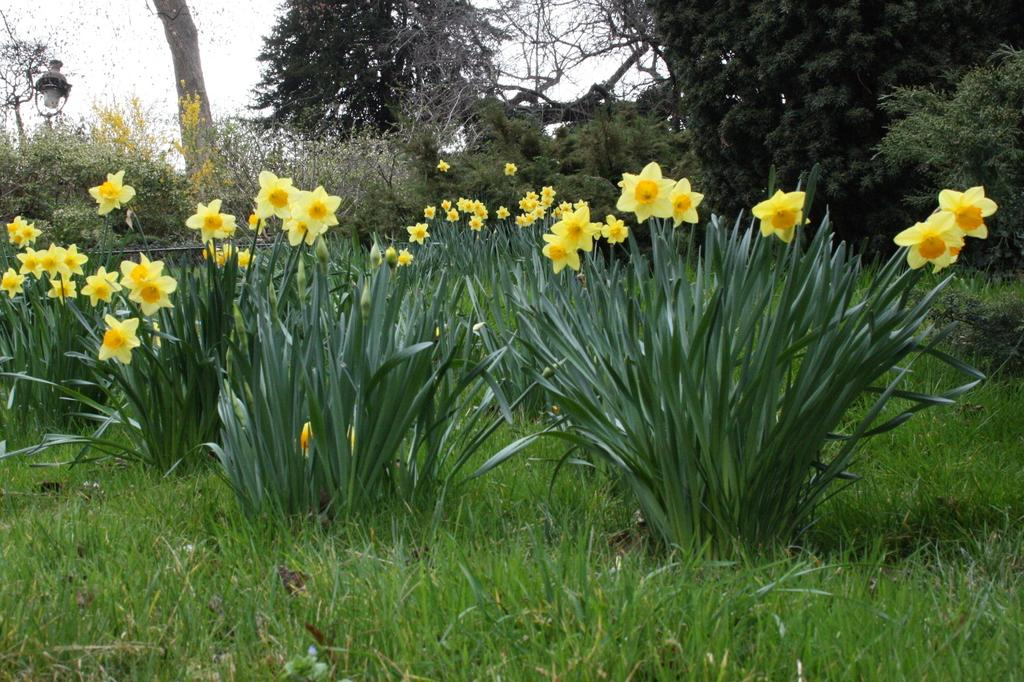What type of vegetation is present on the ground in the image? There is grass on the ground in the image. What other types of vegetation can be seen in the image? There are flowers, plants, and trees in the image. Can you describe the object on the left side of the image? Unfortunately, the facts provided do not give any information about the object on the left side of the image. What idea does the parent have about the spade in the image? There is no parent or spade present in the image, so it is not possible to answer that question. 